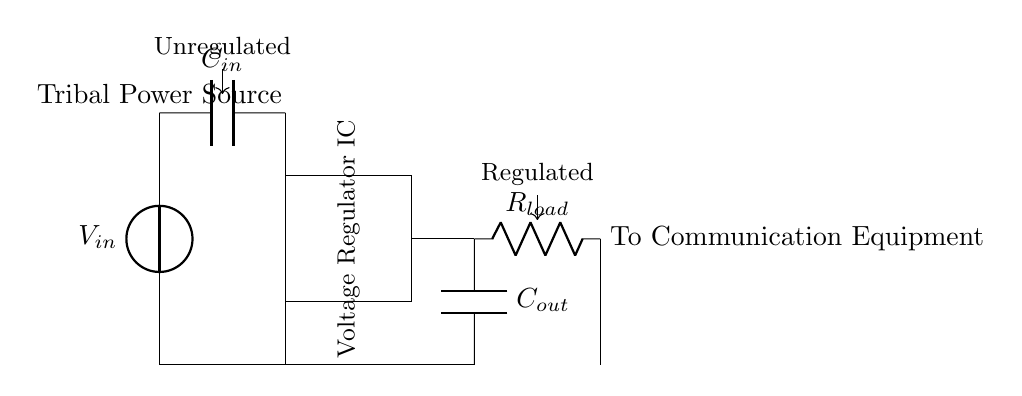What is the input voltage source labeled as? The input voltage source is labeled as V_in, indicating it is the power source feeding into the voltage regulator circuit.
Answer: V_in What component regulates the voltage in this circuit? The component that regulates the voltage is the Voltage Regulator IC. It is specifically designed for maintaining a constant output voltage regardless of variations in input voltage or load conditions.
Answer: Voltage Regulator IC What is the purpose of the capacitor labeled C_out? The purpose of the capacitor labeled C_out is to smooth the output voltage by reducing voltage fluctuations and filtering noise from the regulated voltage supply, helping to ensure a stable output for the connected communication equipment.
Answer: Filtering noise How are the ground connections made in the circuit? The ground connections are made by connecting the bottom terminals of the components to a common ground line, shown in the circuit diagram as a horizontal line at the bottom, which indicates the reference point for the circuit.
Answer: Common ground line What is the load resistor connected to? The load resistor is connected to the output of the voltage regulator and provides the resistance for the electrical load, which in this case represents the tribal communication equipment that relies on the power supply.
Answer: Output of the regulator Which component is used at the input of the voltage regulator? The component used at the input of the voltage regulator is the capacitor labeled C_in, which helps stabilize the input voltage by reducing fluctuations before it reaches the voltage regulator.
Answer: C_in What does the output label indicate about the provided voltage? The output label indicates that the voltage is regulated, meaning it has been stabilized by the voltage regulator, so it can deliver a consistent voltage level to the communication equipment, ensuring reliable operation.
Answer: Regulated 